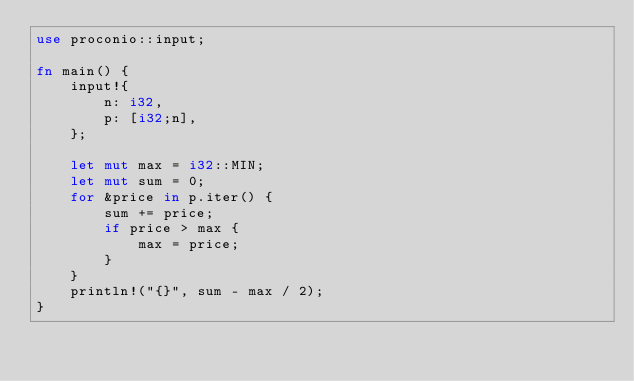Convert code to text. <code><loc_0><loc_0><loc_500><loc_500><_Rust_>use proconio::input;

fn main() {
    input!{
        n: i32,
        p: [i32;n],
    };

    let mut max = i32::MIN;
    let mut sum = 0;
    for &price in p.iter() {
        sum += price;
        if price > max {
            max = price;
        }
    }
    println!("{}", sum - max / 2);
}
</code> 